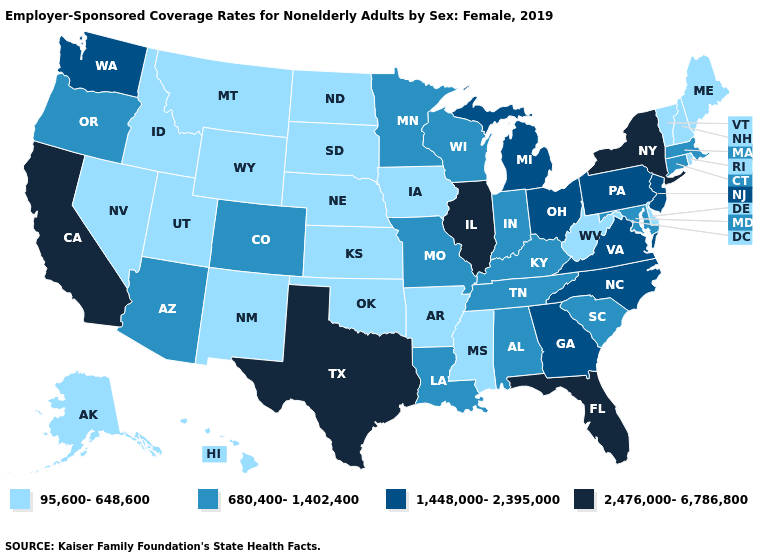Which states have the lowest value in the USA?
Answer briefly. Alaska, Arkansas, Delaware, Hawaii, Idaho, Iowa, Kansas, Maine, Mississippi, Montana, Nebraska, Nevada, New Hampshire, New Mexico, North Dakota, Oklahoma, Rhode Island, South Dakota, Utah, Vermont, West Virginia, Wyoming. What is the lowest value in the USA?
Give a very brief answer. 95,600-648,600. Name the states that have a value in the range 2,476,000-6,786,800?
Answer briefly. California, Florida, Illinois, New York, Texas. Does the first symbol in the legend represent the smallest category?
Give a very brief answer. Yes. Does Maine have the same value as West Virginia?
Answer briefly. Yes. What is the highest value in the USA?
Quick response, please. 2,476,000-6,786,800. What is the highest value in the MidWest ?
Write a very short answer. 2,476,000-6,786,800. What is the lowest value in states that border Iowa?
Be succinct. 95,600-648,600. Is the legend a continuous bar?
Keep it brief. No. Name the states that have a value in the range 95,600-648,600?
Write a very short answer. Alaska, Arkansas, Delaware, Hawaii, Idaho, Iowa, Kansas, Maine, Mississippi, Montana, Nebraska, Nevada, New Hampshire, New Mexico, North Dakota, Oklahoma, Rhode Island, South Dakota, Utah, Vermont, West Virginia, Wyoming. What is the value of Maryland?
Give a very brief answer. 680,400-1,402,400. Name the states that have a value in the range 1,448,000-2,395,000?
Keep it brief. Georgia, Michigan, New Jersey, North Carolina, Ohio, Pennsylvania, Virginia, Washington. Which states have the lowest value in the USA?
Short answer required. Alaska, Arkansas, Delaware, Hawaii, Idaho, Iowa, Kansas, Maine, Mississippi, Montana, Nebraska, Nevada, New Hampshire, New Mexico, North Dakota, Oklahoma, Rhode Island, South Dakota, Utah, Vermont, West Virginia, Wyoming. What is the lowest value in states that border Louisiana?
Concise answer only. 95,600-648,600. 